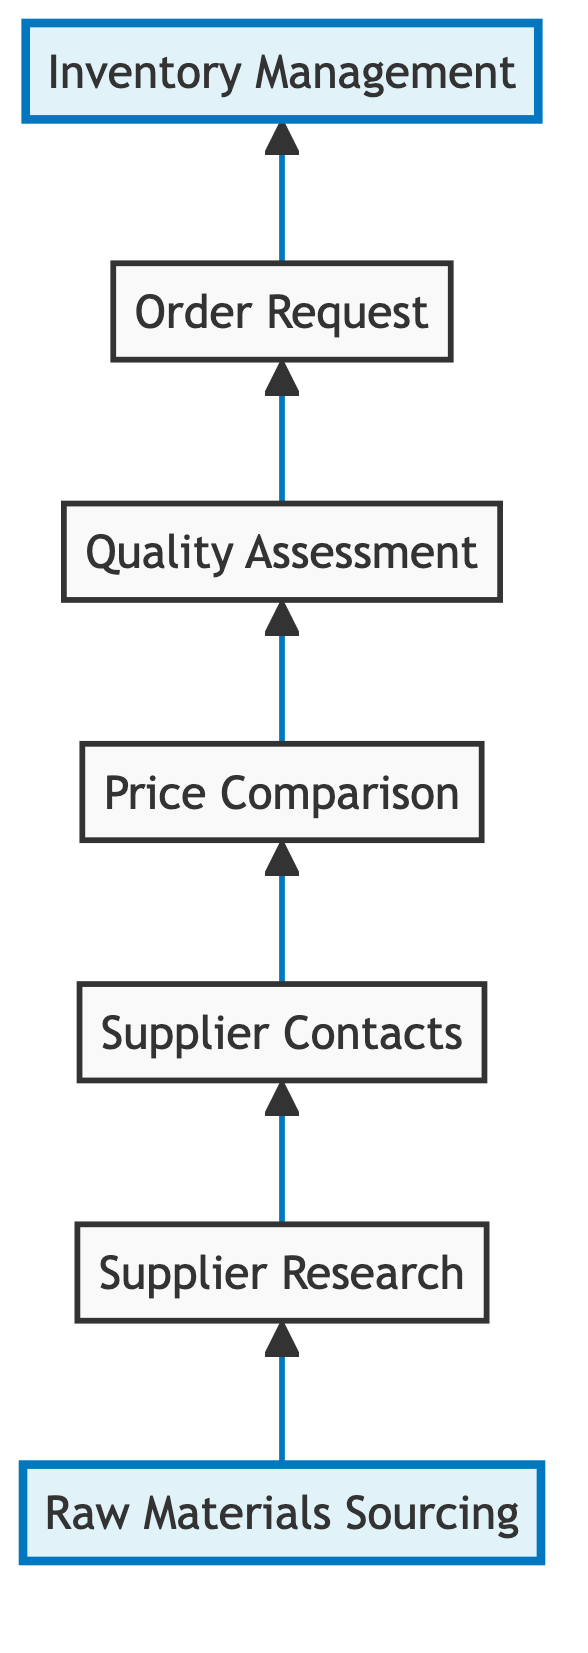What is the first step in the material sourcing workflow? The first step is labeled as "Raw Materials Sourcing," which identifies the types of materials needed for handmade jewelry. This is clearly indicated as the initial node in the diagram.
Answer: Raw Materials Sourcing How many nodes are in the diagram? By counting the distinct elements in the diagram, we find there are a total of seven nodes representing different steps in the material sourcing workflow.
Answer: Seven What is "Order Request" connected to? "Order Request" is a node that specifically connects to "Inventory Management," showing the flow of the process. The arrow indicates that after the order has been placed, the next step is inventory management.
Answer: Inventory Management Which step involves evaluating samples from suppliers? The step named "Quality Assessment" describes the process of evaluating samples from suppliers to ensure materials meet quality standards for handmade jewelry. This is also a specific node in the workflow, indicating its importance.
Answer: Quality Assessment Which node follows "Price Comparison"? The node that directly follows "Price Comparison" is called "Quality Assessment," representing that after comparing prices, the next action involves assessing the quality of the materials. This shows a sequential flow in the sourcing process.
Answer: Quality Assessment What is the last step in the material sourcing workflow? The last step in the workflow is "Inventory Management," which indicates that after orders are placed, inventory tracking and management of received materials start. This is deduced from the flowchart’s final connection.
Answer: Inventory Management How many connections are in the diagram? There are six directional connections displayed in the flowchart, each connecting one node to the next in the material sourcing workflow. This allows us to map out the entire process sequentially.
Answer: Six What is the main purpose of the "Supplier Research" step? The step "Supplier Research" serves the primary function of conducting research to find reputable suppliers that provide quality materials. This step is essential in ensuring that the sourcing process starts on a strong foundation.
Answer: Conduct research to find suppliers 